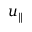Convert formula to latex. <formula><loc_0><loc_0><loc_500><loc_500>u _ { \| }</formula> 